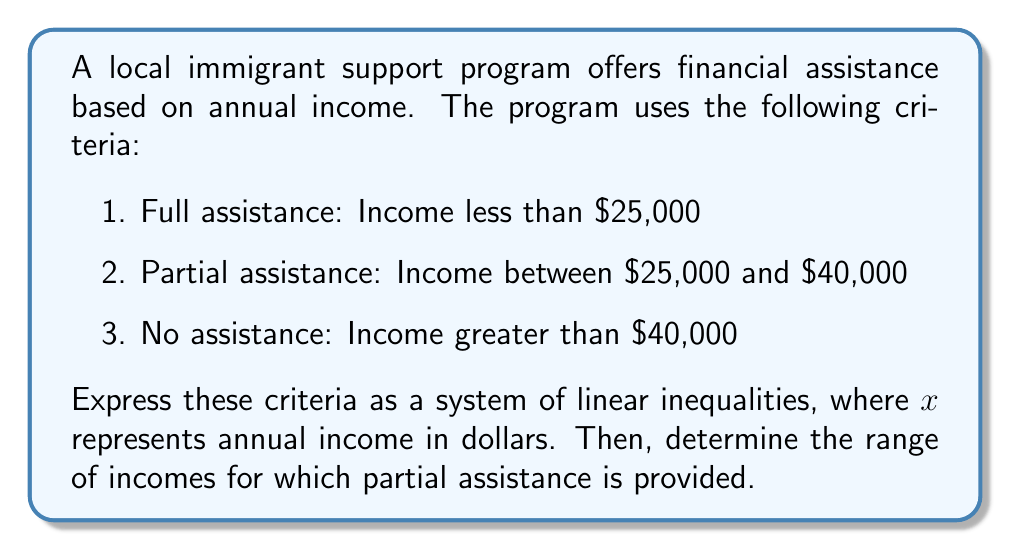Solve this math problem. Let's approach this step-by-step:

1) First, we need to express each criterion as a linear inequality:

   Full assistance: $x < 25000$
   Partial assistance: $25000 \leq x \leq 40000$
   No assistance: $x > 40000$

2) The system of linear inequalities can be written as:

   $$
   \begin{cases}
   x < 25000 & \text{(Full assistance)} \\
   25000 \leq x \leq 40000 & \text{(Partial assistance)} \\
   x > 40000 & \text{(No assistance)}
   \end{cases}
   $$

3) To determine the range of incomes for partial assistance, we focus on the middle inequality:

   $25000 \leq x \leq 40000$

4) This inequality can be read as "x is greater than or equal to 25000 and less than or equal to 40000".

5) In interval notation, this is written as $[25000, 40000]$.

Therefore, partial assistance is provided for incomes in the range $[25000, 40000]$, or from $25,000 to $40,000 inclusive.
Answer: $[25000, 40000]$ 